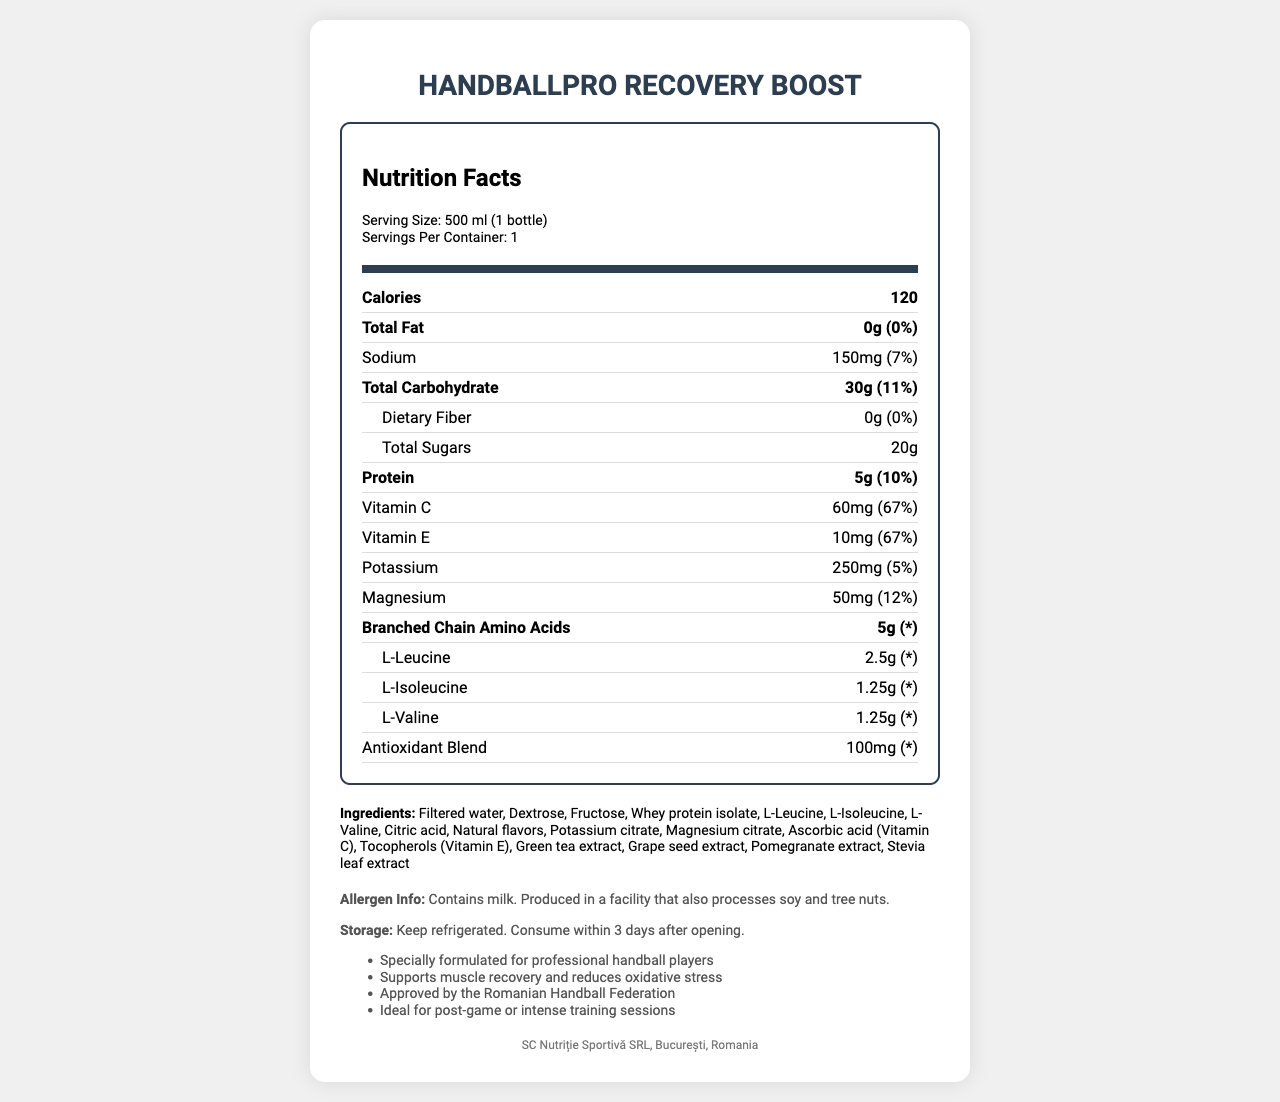what is the serving size? The serving size is explicitly stated in the serving info section at the top part of the nutrition label.
Answer: 500 ml (1 bottle) how many calories are in one serving? The calories per serving are shown in the bold nutrient row labeled "Calories."
Answer: 120 what percentage of the daily value of Vitamin C is provided? This information is found in the nutrient row for Vitamin C, showing 60mg corresponding to 67% of the daily value.
Answer: 67% what is the sodium content in this recovery drink? The sodium content is listed in the nutrient row for Sodium.
Answer: 150mg how many grams of protein are in this drink? The amount of protein is shown in the bold nutrient row labeled "Protein."
Answer: 5g how many servings are in the container? This information is provided in the serving info section.
Answer: 1 what are the main ingredients in the HandballPro Recovery Boost? The main ingredients are listed in the ingredients section.
Answer: Filtered water, Dextrose, Fructose, Whey protein isolate, L-Leucine, L-Isoleucine, L-Valine, Citric acid, Natural flavors, Potassium citrate, Magnesium citrate, Ascorbic acid (Vitamin C), Tocopherols (Vitamin E), Green tea extract, Grape seed extract, Pomegranate extract, Stevia leaf extract how should the drink be stored? The storage instructions are provided in the additional info section.
Answer: Keep refrigerated. Consume within 3 days after opening. what company manufactures the HandballPro Recovery Boost? The manufacturer is listed at the bottom of the document.
Answer: SC Nutriție Sportivă SRL, București, Romania what is the total carbohydrate content for one serving? A. 10g B. 20g C. 30g D. 40g The total carbohydrate content is shown as 30g in the bold nutrient row for Total Carbohydrate.
Answer: C is this recovery drink suitable for someone with a soy allergy? The allergen info states that it is produced in a facility that also processes soy.
Answer: No can you summarize the main components and benefits of the HandballPro Recovery Boost? The main components and benefits can be summarized from the detailed information provided in the document, including its nutritional content, ingredients, and additional information sections.
Answer: The HandballPro Recovery Boost is a specially formulated post-game recovery drink for professional handball players. It provides 120 calories per serving with 5g of protein, 30g of carbohydrates, and an antioxidant blend to support muscle recovery and reduce oxidative stress. The drink contains branched-chain amino acids (BCAAs) and essential electrolytes like potassium and magnesium and is approved by the Romanian Handball Federation. how much green tea extract is in this drink? The document lists the antioxidant blend as 100mg but does not specify the amount of green tea extract separately.
Answer: Not enough information 